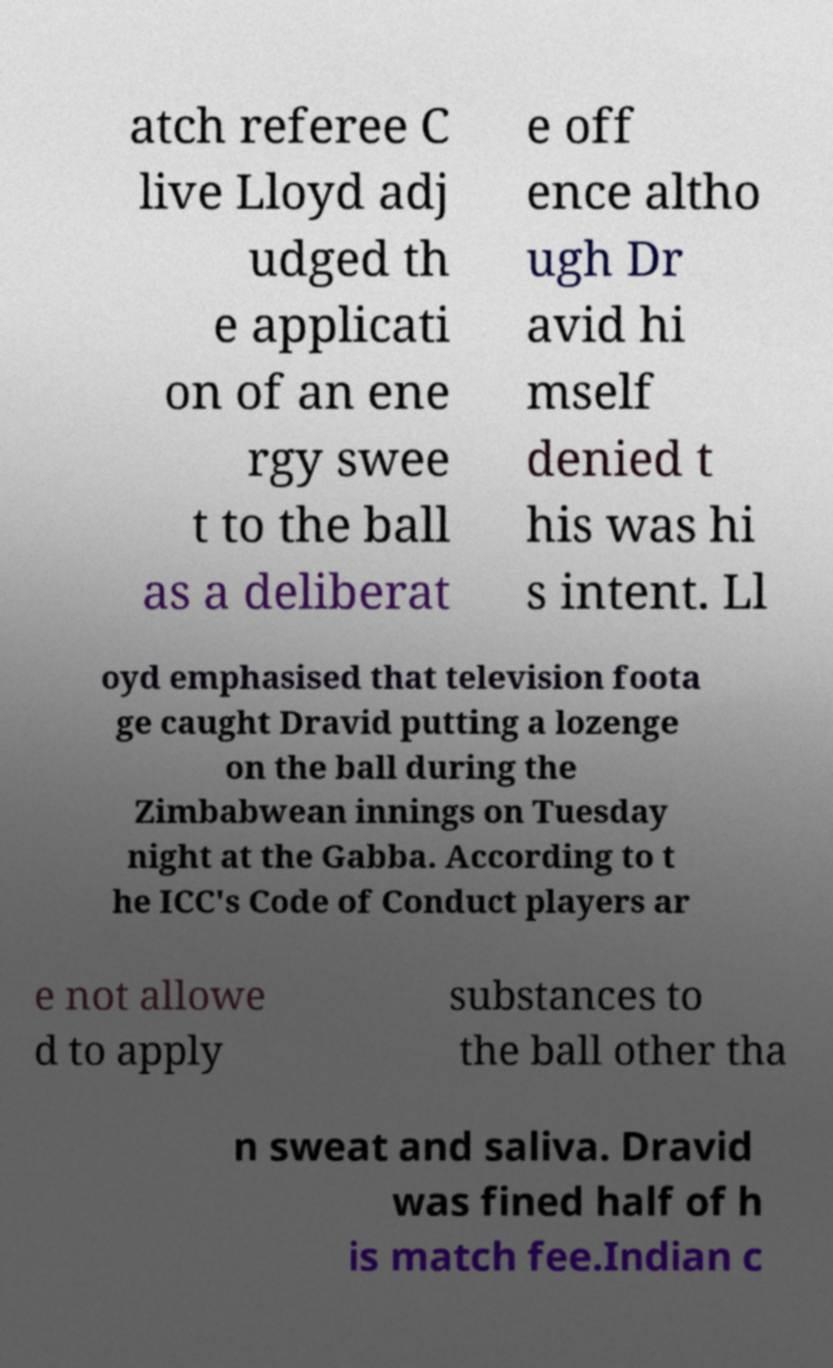I need the written content from this picture converted into text. Can you do that? atch referee C live Lloyd adj udged th e applicati on of an ene rgy swee t to the ball as a deliberat e off ence altho ugh Dr avid hi mself denied t his was hi s intent. Ll oyd emphasised that television foota ge caught Dravid putting a lozenge on the ball during the Zimbabwean innings on Tuesday night at the Gabba. According to t he ICC's Code of Conduct players ar e not allowe d to apply substances to the ball other tha n sweat and saliva. Dravid was fined half of h is match fee.Indian c 